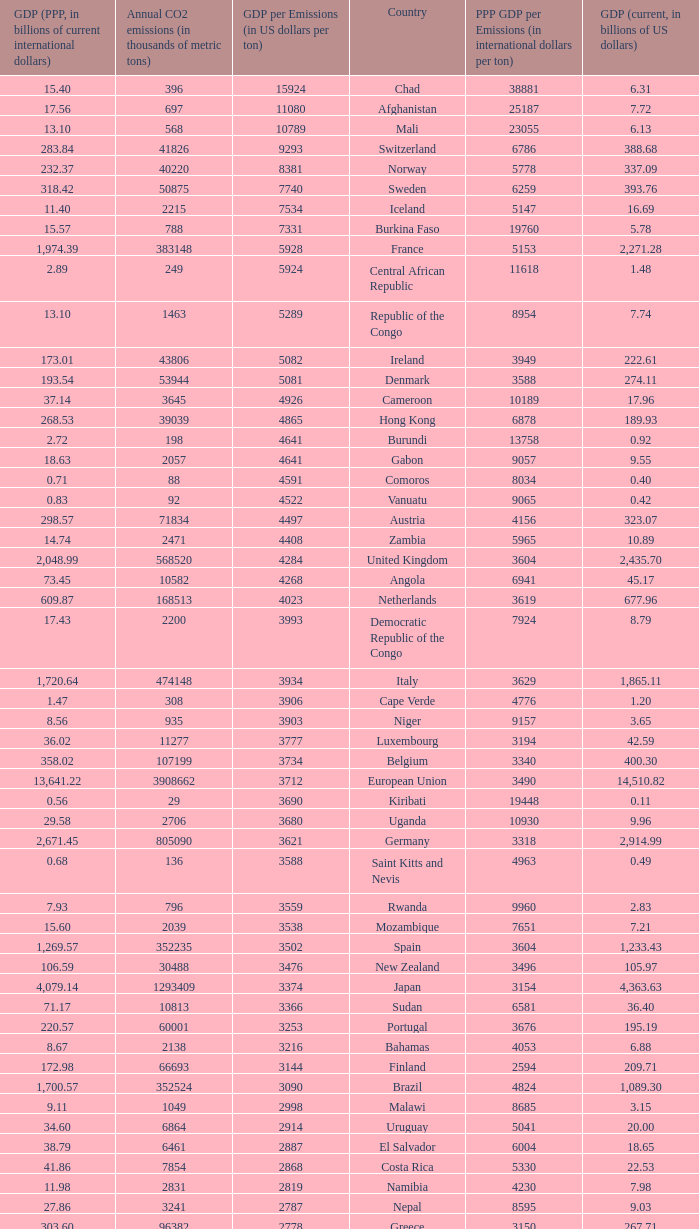With a gdp per emissions value of $3,903 per ton, what is the greatest amount of co2 emissions per year in thousands of metric tons? 935.0. 